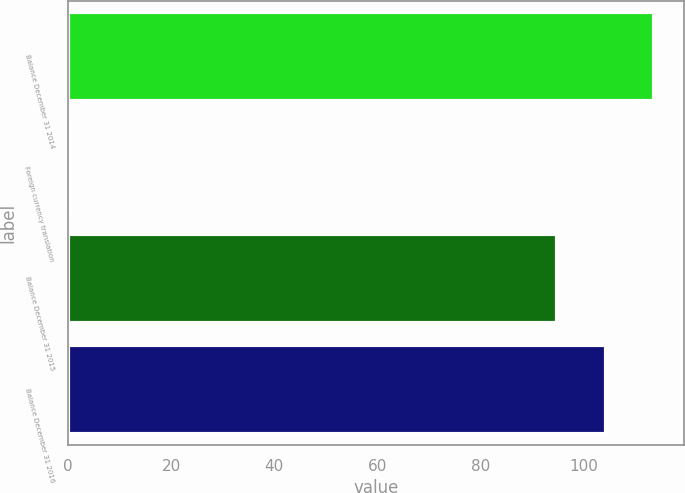<chart> <loc_0><loc_0><loc_500><loc_500><bar_chart><fcel>Balance December 31 2014<fcel>Foreign currency translation<fcel>Balance December 31 2015<fcel>Balance December 31 2016<nl><fcel>113.64<fcel>0.5<fcel>94.7<fcel>104.17<nl></chart> 